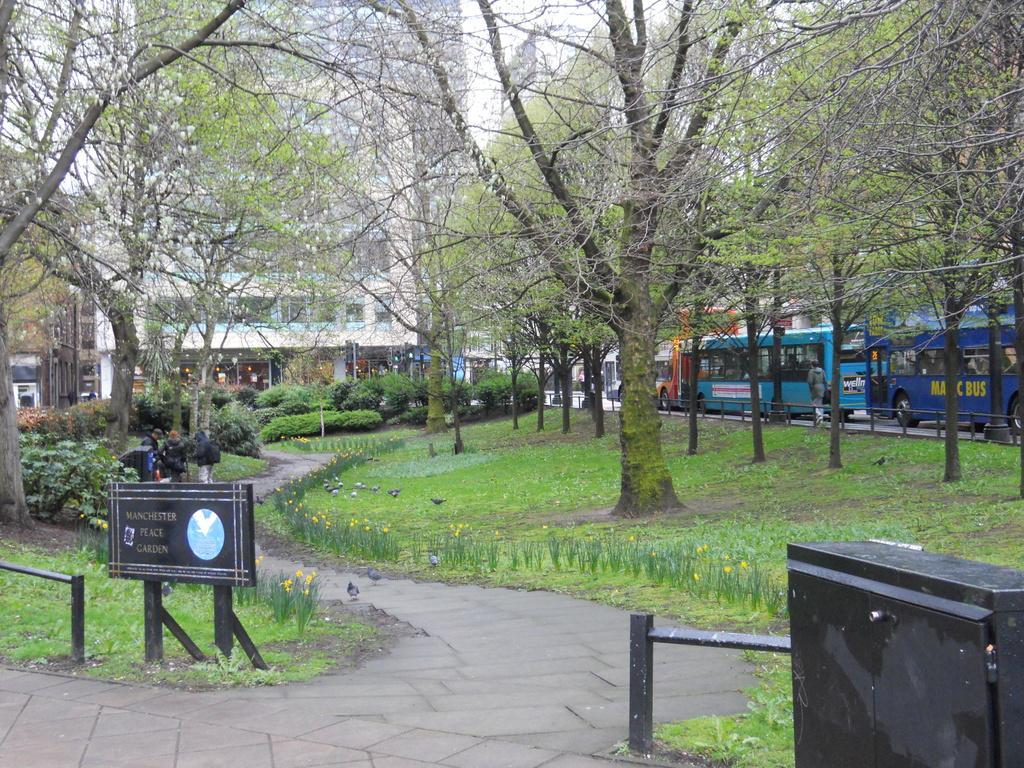In one or two sentences, can you explain what this image depicts? In this image I can see a walking lane with some trees. On the right side I can see some buses. In the background I can see a building. 